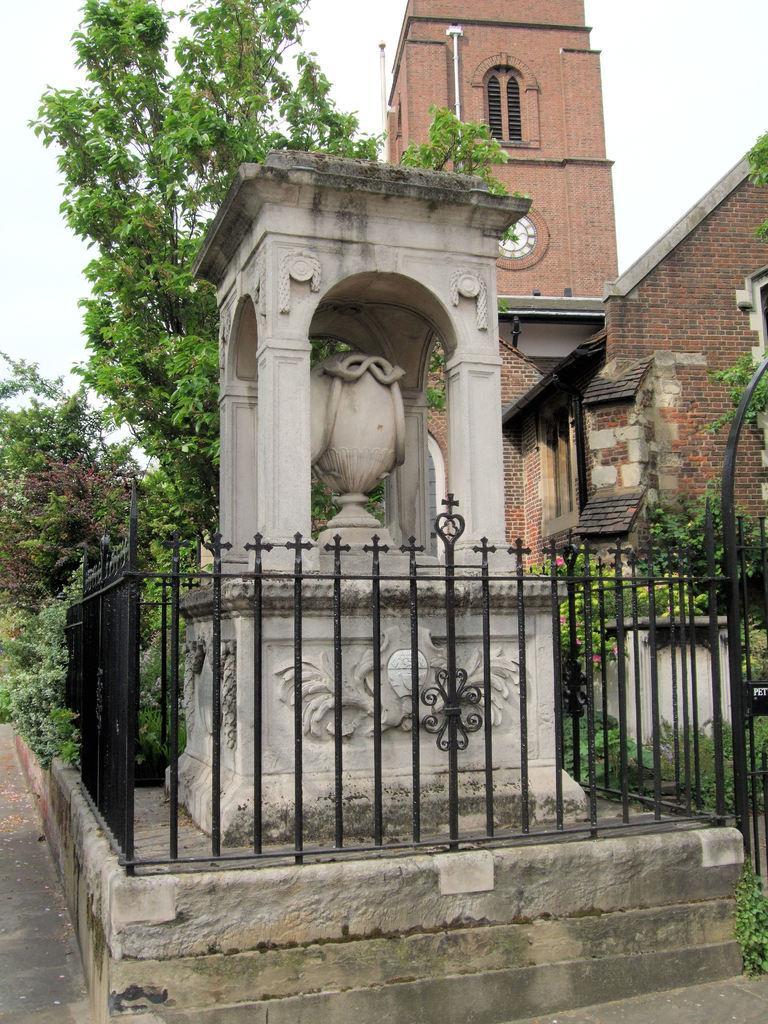Please provide a concise description of this image. In this image I can see a building, a clock on the building tower, fence, trees and other objects on the ground. In the background I can see the sky. 